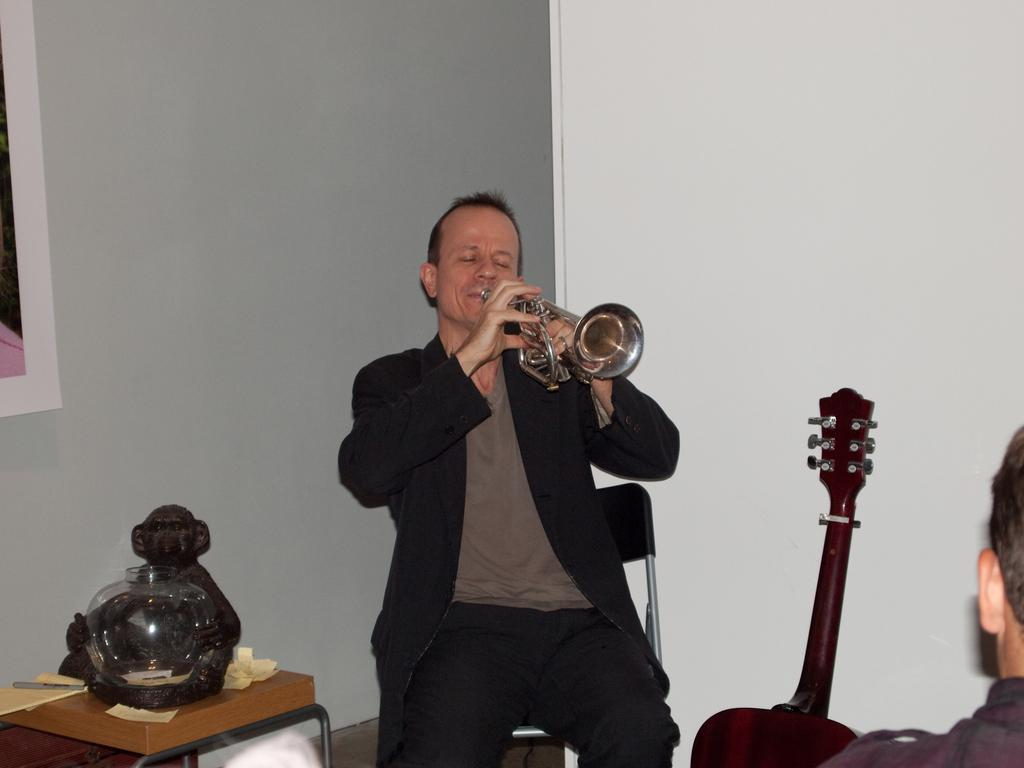What is the man in the image doing? The man is playing a musical instrument. What instrument is the man playing? The provided facts do not specify the type of musical instrument the man is playing. What object is beside the man? There is a guitar beside the man. What is on the table in the image? There is a statue of a monkey on the table. What is the monkey statue holding? The monkey statue is holding a bowl in its hand. What type of lawyer is depicted in the image? There is no lawyer present in the image; it features a man playing a musical instrument, a guitar, a monkey statue holding a bowl, and a table. How many pieces of lumber can be seen in the image? There is no lumber present in the image. 